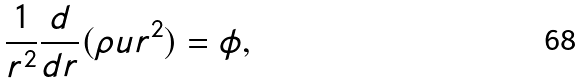<formula> <loc_0><loc_0><loc_500><loc_500>\frac { 1 } { r ^ { 2 } } \frac { d } { d r } ( \rho u r ^ { 2 } ) = \phi ,</formula> 